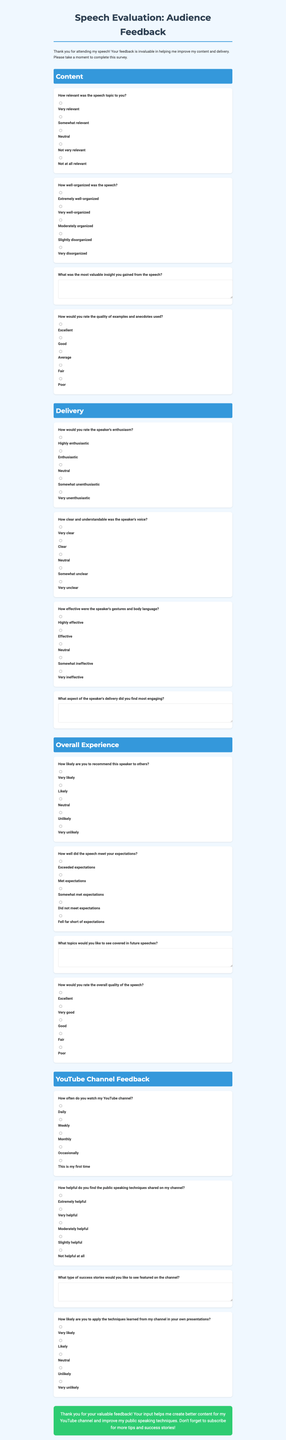What is the title of the form? The title is stated at the beginning of the document.
Answer: Speech Evaluation: Audience Feedback How many sections are in the form? The document lists several sections that categorize the questions.
Answer: Four What type of feedback is requested in the first open-ended question? The first open-ended question seeks a specific insight from the speech.
Answer: Most valuable insight How likely are respondents to recommend the speaker to others? This is a question listed in the Overall Experience section, assessing recommendation likelihood.
Answer: Very likely What is the background color of the document? The background color is described in the styling section of the document.
Answer: Light blue How often do the respondents watch the YouTube channel? This question is included in the YouTube Channel Feedback section, assessing viewing frequency.
Answer: Daily What is the closing message of the document? The closing message summarizes the purpose of the feedback and encourages further engagement.
Answer: Thank you for your valuable feedback! 